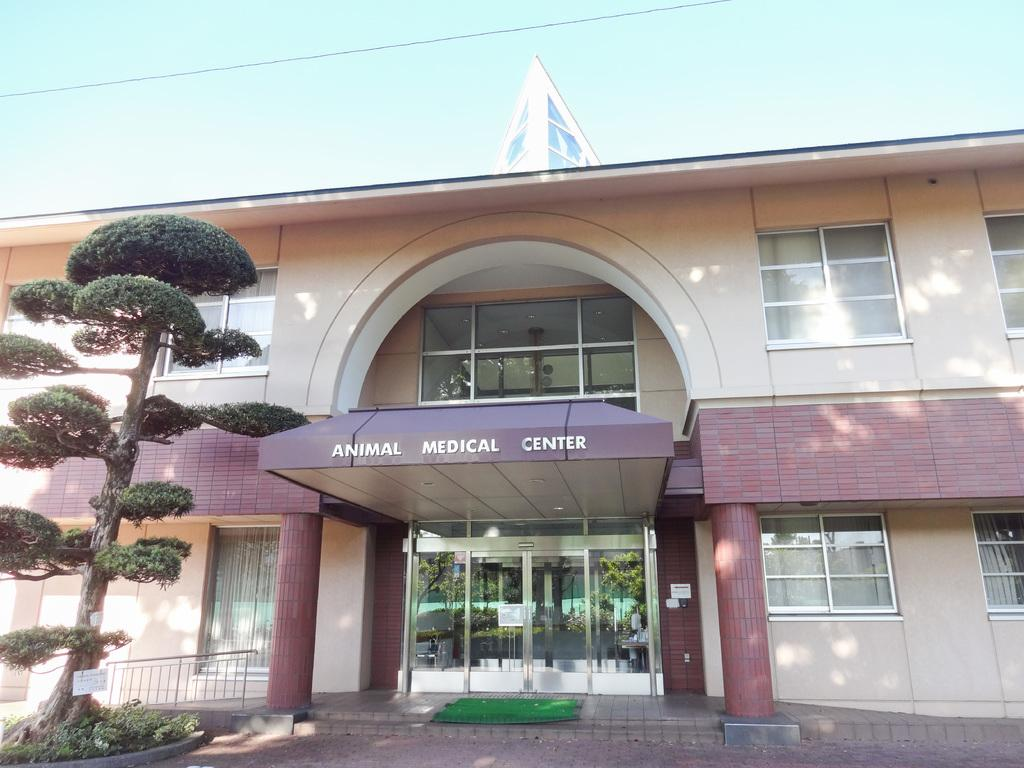<image>
Describe the image concisely. Animal Medical Center that takes care of pets. 